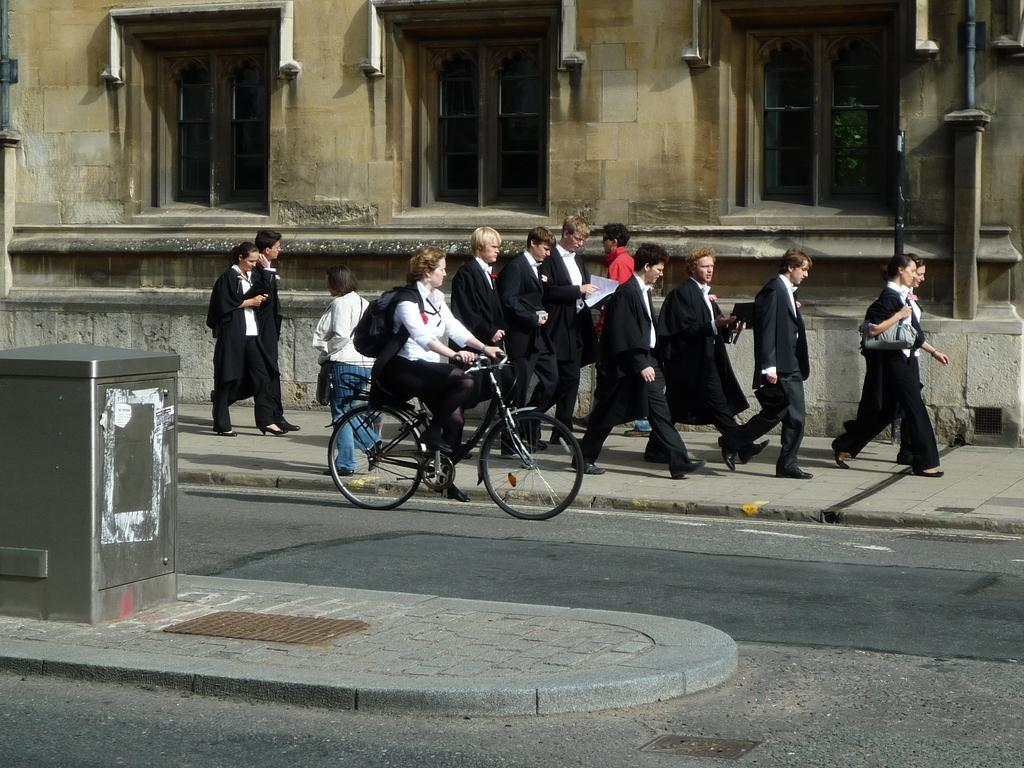What is the woman in the image doing? The woman is riding a bicycle in the image. What are the people behind the woman doing? The people walking on the road behind the woman are walking. What can be seen in the background of the image? There is a building visible at the top of the image. What is the woman holding in the image? The person mentioned is holding a bag. What type of butter can be seen melting on the road in the image? There is no butter present in the image; it features a woman riding a bicycle and people walking on the road. 